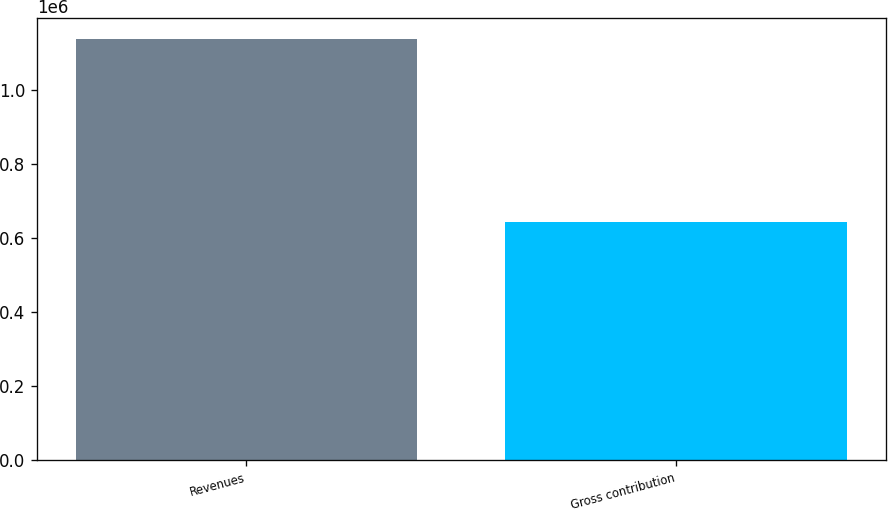Convert chart. <chart><loc_0><loc_0><loc_500><loc_500><bar_chart><fcel>Revenues<fcel>Gross contribution<nl><fcel>1.1398e+06<fcel>642906<nl></chart> 